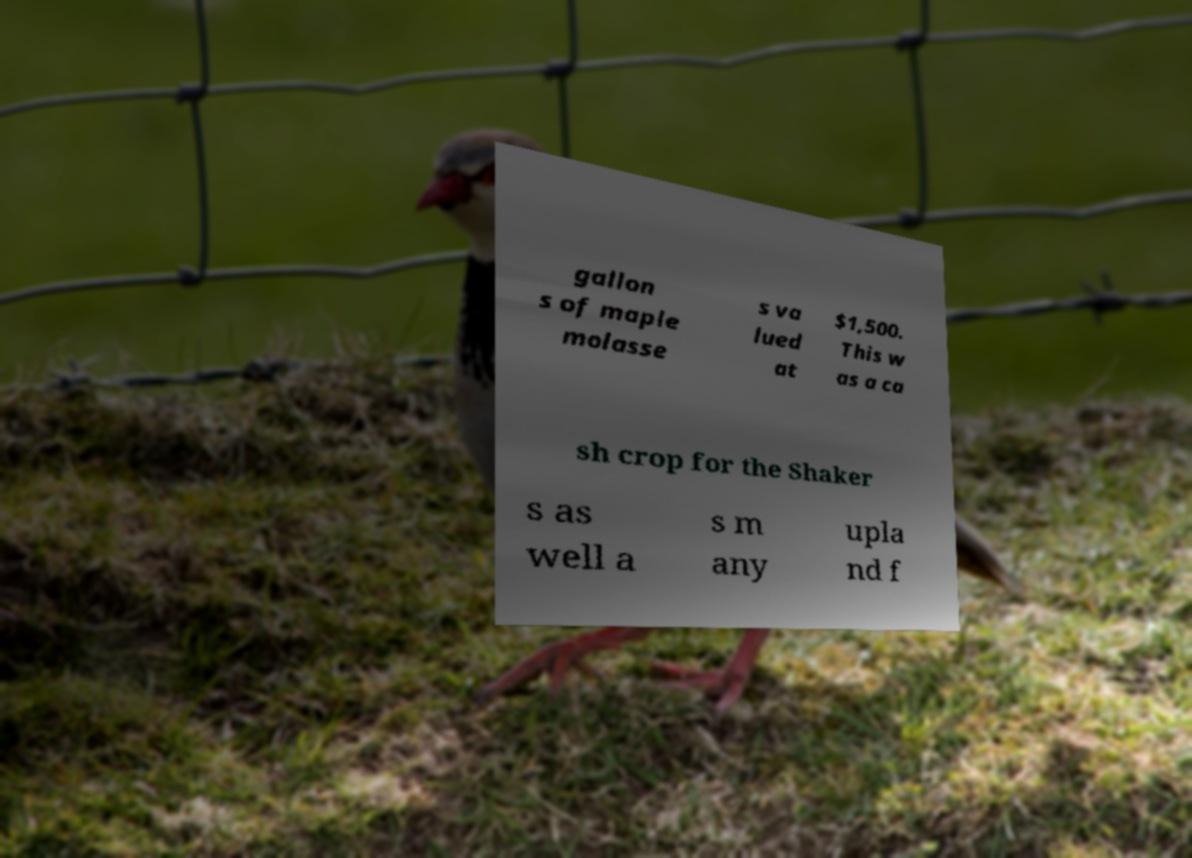I need the written content from this picture converted into text. Can you do that? gallon s of maple molasse s va lued at $1,500. This w as a ca sh crop for the Shaker s as well a s m any upla nd f 